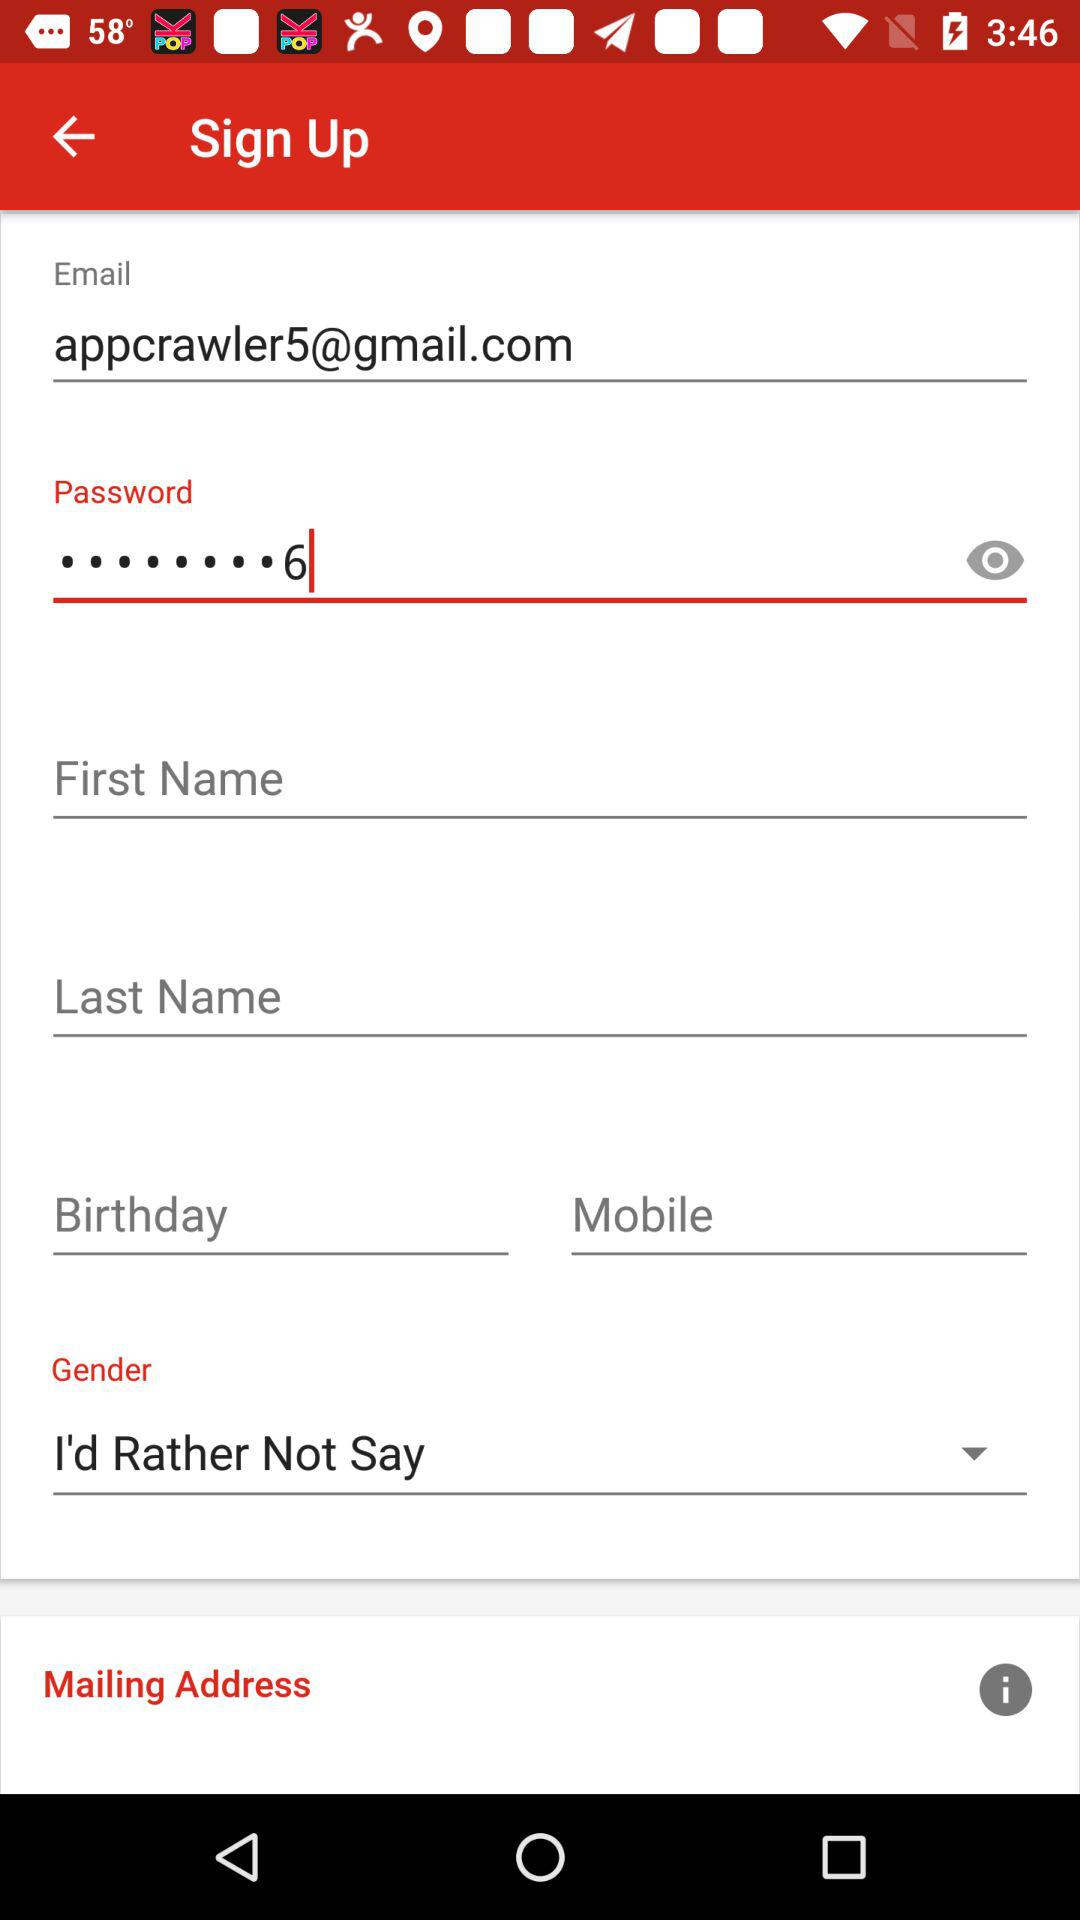What gender is selected? The selected gender is "I'd Rather Not Say". 